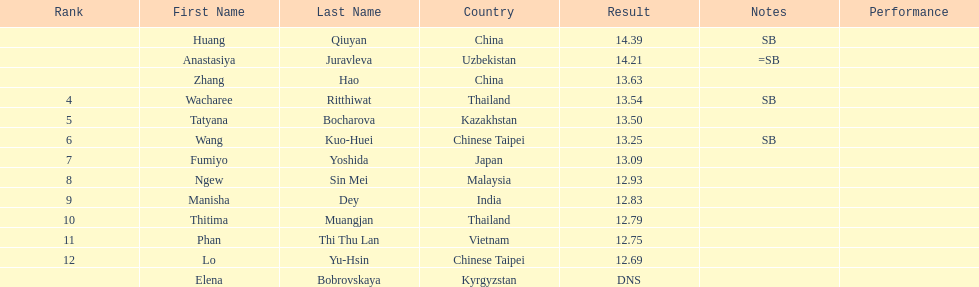How many people were ranked? 12. 